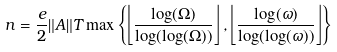Convert formula to latex. <formula><loc_0><loc_0><loc_500><loc_500>n = \frac { e } { 2 } \| A \| T \max \left \{ \left \lfloor \frac { \log ( \Omega ) } { \log ( \log ( \Omega ) ) } \right \rfloor , \left \lfloor \frac { \log ( \omega ) } { \log ( \log ( \omega ) ) } \right \rfloor \right \}</formula> 